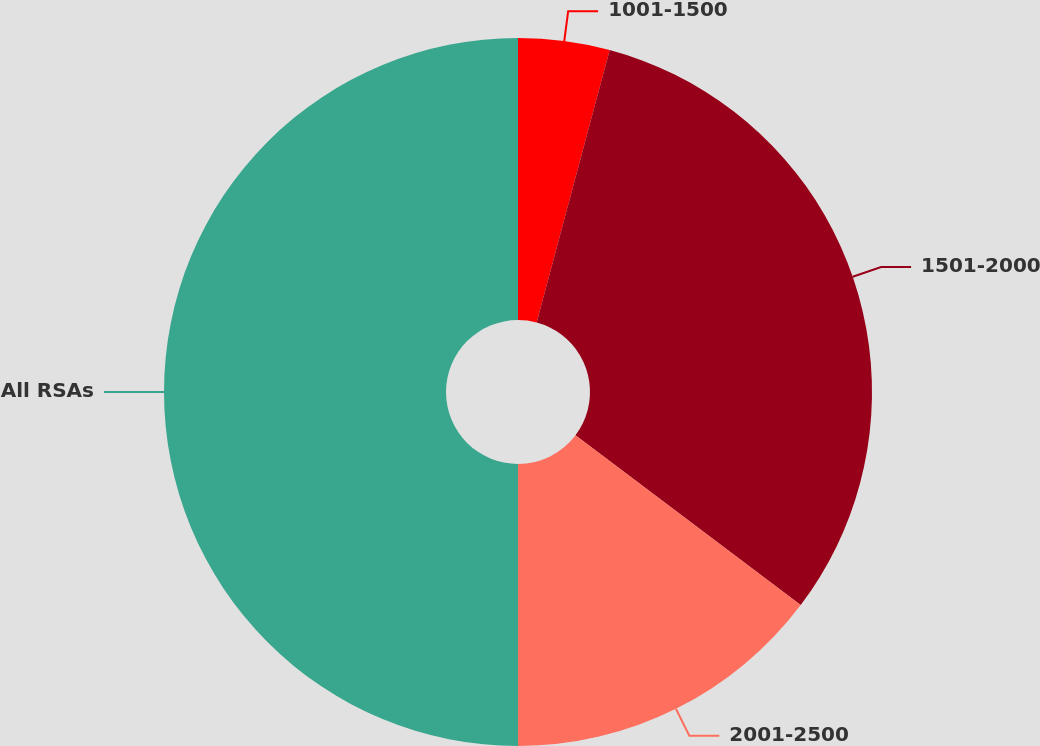<chart> <loc_0><loc_0><loc_500><loc_500><pie_chart><fcel>1001-1500<fcel>1501-2000<fcel>2001-2500<fcel>All RSAs<nl><fcel>4.17%<fcel>31.11%<fcel>14.72%<fcel>50.0%<nl></chart> 